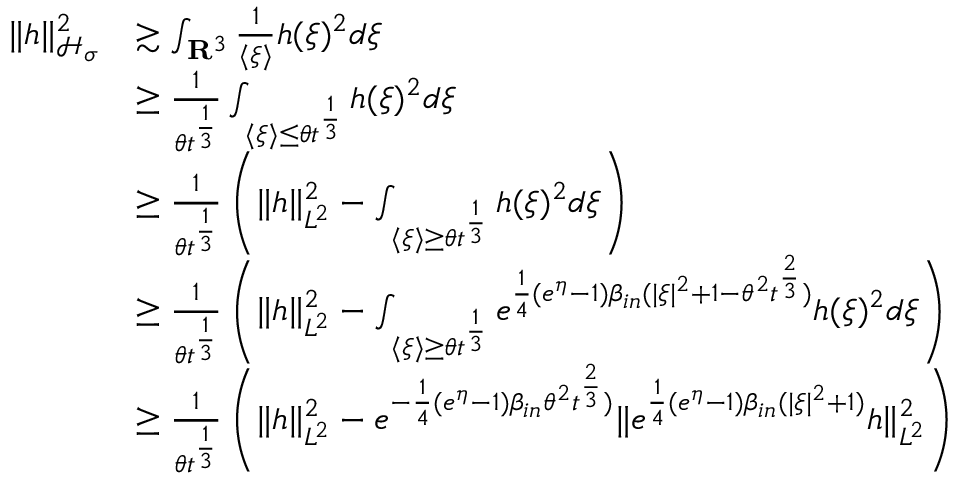Convert formula to latex. <formula><loc_0><loc_0><loc_500><loc_500>\begin{array} { r l } { \| h \| _ { \mathcal { H } _ { \sigma } } ^ { 2 } } & { \gtrsim \int _ { \mathbf R ^ { 3 } } \frac { 1 } { \langle \xi \rangle } h ( \xi ) ^ { 2 } d \xi } \\ & { \geq \frac { 1 } { \theta t ^ { \frac { 1 } { 3 } } } \int _ { \langle \xi \rangle \leq \theta t ^ { \frac { 1 } { 3 } } } h ( \xi ) ^ { 2 } d \xi } \\ & { \geq \frac { 1 } { \theta t ^ { \frac { 1 } { 3 } } } \left ( \| h \| _ { L ^ { 2 } } ^ { 2 } - \int _ { \langle \xi \rangle \geq \theta t ^ { \frac { 1 } { 3 } } } h ( \xi ) ^ { 2 } d \xi \right ) } \\ & { \geq \frac { 1 } { \theta t ^ { \frac { 1 } { 3 } } } \left ( \| h \| _ { L ^ { 2 } } ^ { 2 } - \int _ { \langle \xi \rangle \geq \theta t ^ { \frac { 1 } { 3 } } } e ^ { \frac { 1 } { 4 } ( e ^ { \eta } - 1 ) \beta _ { i n } ( | \xi | ^ { 2 } + 1 - \theta ^ { 2 } t ^ { \frac { 2 } { 3 } } ) } h ( \xi ) ^ { 2 } d \xi \right ) } \\ & { \geq \frac { 1 } { \theta t ^ { \frac { 1 } { 3 } } } \left ( \| h \| _ { L ^ { 2 } } ^ { 2 } - e ^ { - \frac { 1 } { 4 } ( e ^ { \eta } - 1 ) \beta _ { i n } \theta ^ { 2 } t ^ { \frac { 2 } { 3 } } ) } \| e ^ { \frac { 1 } { 4 } ( e ^ { \eta } - 1 ) \beta _ { i n } ( | \xi | ^ { 2 } + 1 ) } h \| _ { L ^ { 2 } } ^ { 2 } \right ) } \end{array}</formula> 